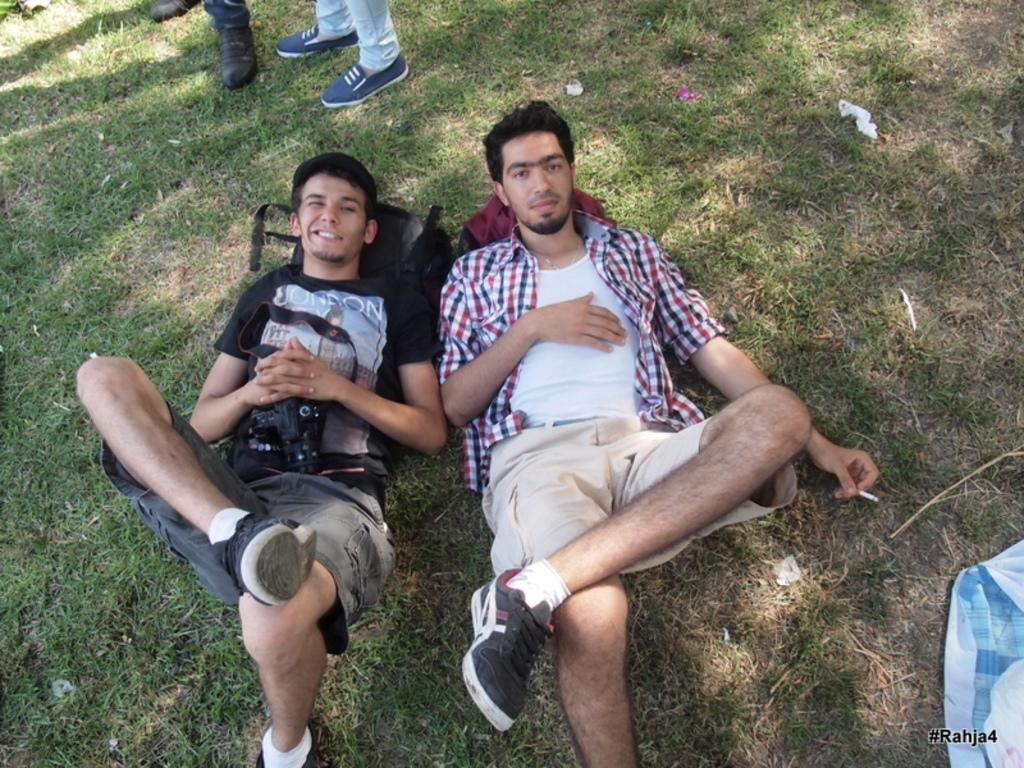What are the two persons in the image doing? The two persons are lying on the floor in the image. What are they holding in their hands? They are holding a cigarette in their hands. Can you describe the people in the background of the image? There are two people standing in the background of the image. What day of the week is it in the image? The day of the week is not mentioned or visible in the image, so it cannot be determined. 